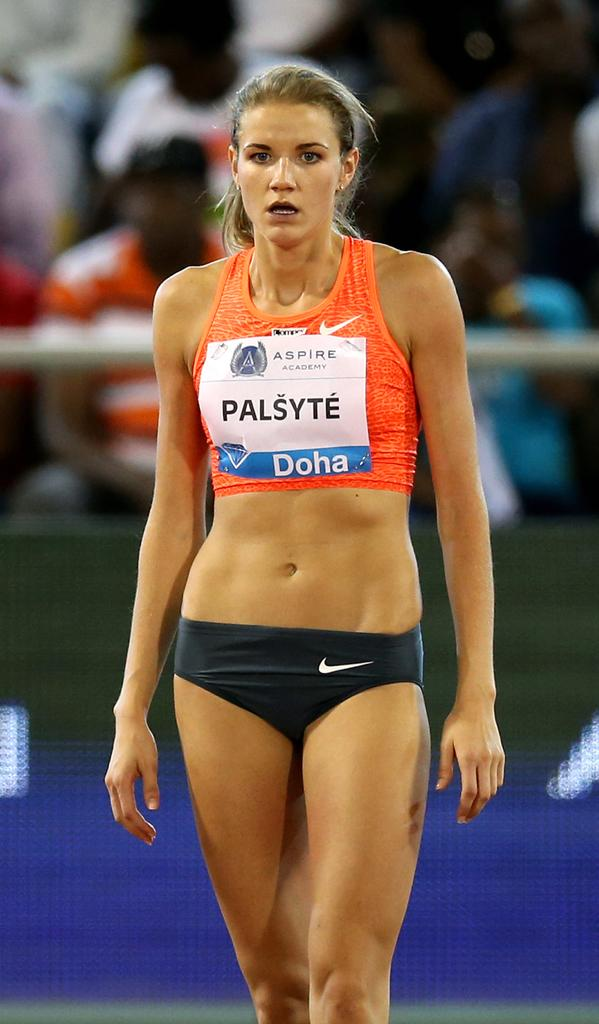What is the primary subject of the image? There is a woman standing in the image. What are the other people in the image doing? There is a group of people sitting in the image. What is separating the people from the woman? The people are sitting behind a rod. What else can be seen in the image? There is a board in the image. What type of chalk is the woman using to draw on the board? There is no chalk or drawing activity present in the image. How does the woman's aunt react to her presence in the image? There is no mention of an aunt in the image, so it is impossible to determine her reaction. 